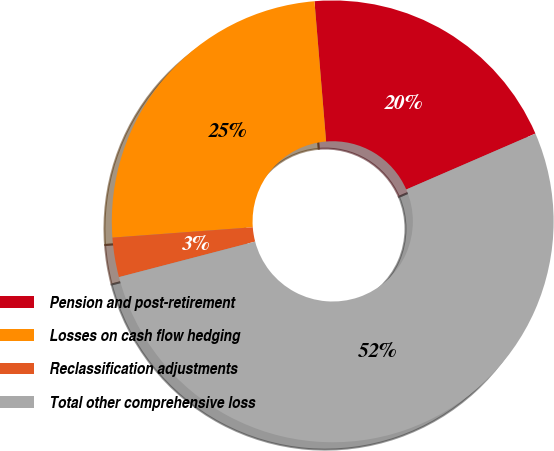<chart> <loc_0><loc_0><loc_500><loc_500><pie_chart><fcel>Pension and post-retirement<fcel>Losses on cash flow hedging<fcel>Reclassification adjustments<fcel>Total other comprehensive loss<nl><fcel>19.81%<fcel>24.86%<fcel>2.89%<fcel>52.45%<nl></chart> 